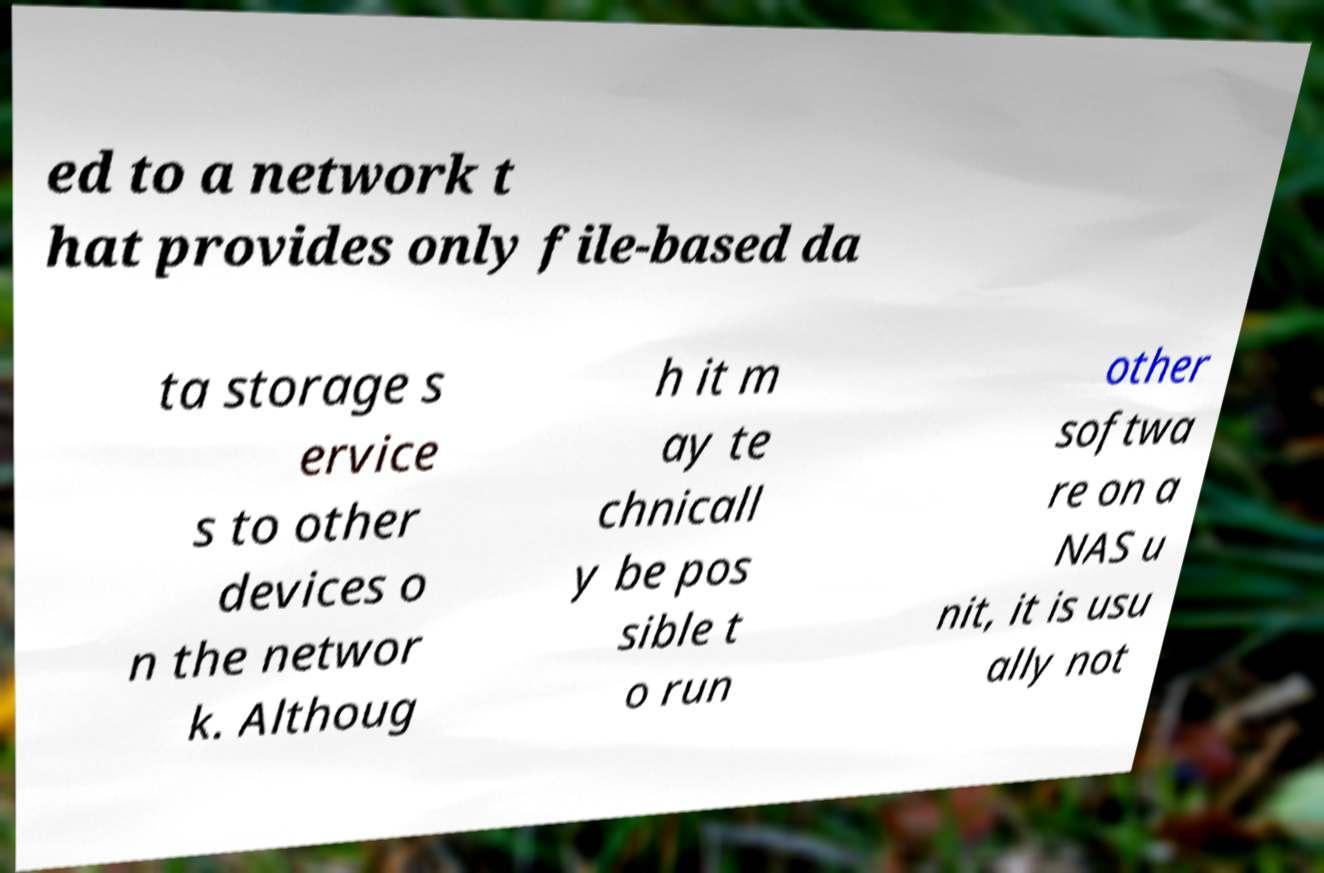Can you read and provide the text displayed in the image?This photo seems to have some interesting text. Can you extract and type it out for me? ed to a network t hat provides only file-based da ta storage s ervice s to other devices o n the networ k. Althoug h it m ay te chnicall y be pos sible t o run other softwa re on a NAS u nit, it is usu ally not 